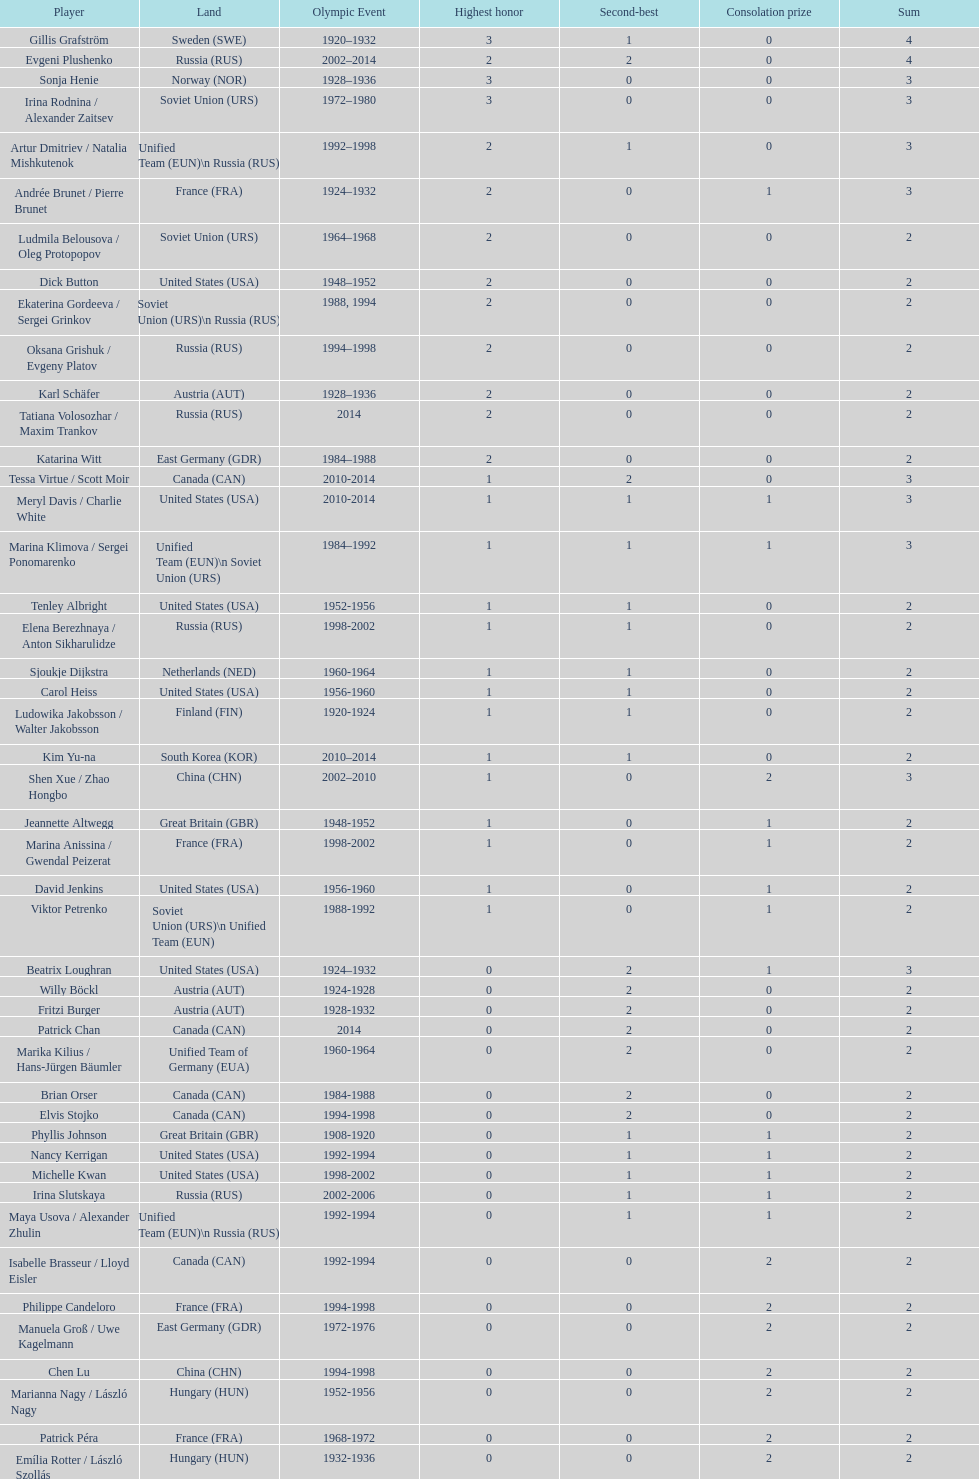In olympic figure skating, which country was the first to earn three gold medals? Sweden. 